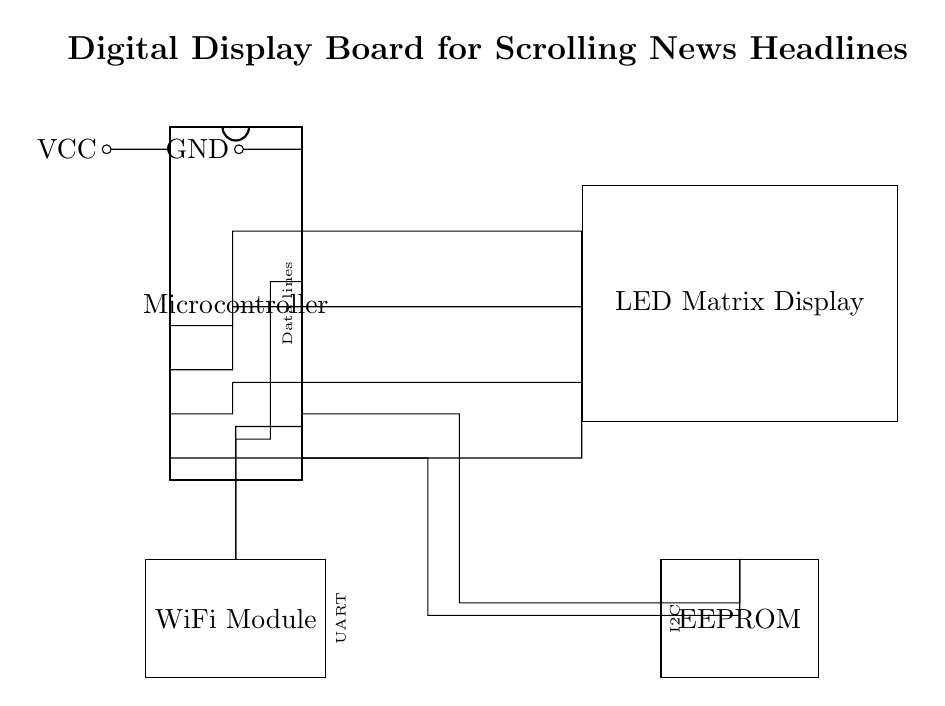What is the microcontroller type? The microcontroller is depicted as a dip chip in the diagram and is the primary component, typically controlling the display and communication with other modules.
Answer: Microcontroller What are the connections for power? The VCC connection provides a positive voltage supply, and the GND connection is for the ground, indicated on pins 1 and 16 of the microcontroller.
Answer: VCC and GND How many data lines are shown in the diagram? The diagram labels the data lines connected to the microcontroller, with four visible connections leading to the LED Matrix Display, as indicated next to the microcontroller.
Answer: Four data lines What is the function of the WiFi module? The WiFi module is connected to the microcontroller and facilitates wireless communication, allowing the display board to receive updates remotely through its UART connection.
Answer: Wireless communication What type of memory is used in this circuit? The diagram indicates the use of EEPROM, which is a non-volatile memory type connected to the microcontroller via I2C, allowing data to be stored even when powered off.
Answer: EEPROM Which component is responsible for displaying the news headlines? The LED Matrix Display is the component shown in the diagram that visually presents the scrolling news headlines by being driven by the microcontroller.
Answer: LED Matrix Display What is the purpose of the data lines connected to the display? The data lines transmit information from the microcontroller to the LED Matrix Display, allowing it to show scrolling text, as identified by the connections from the microcontroller pins to the display.
Answer: Transmitting information 